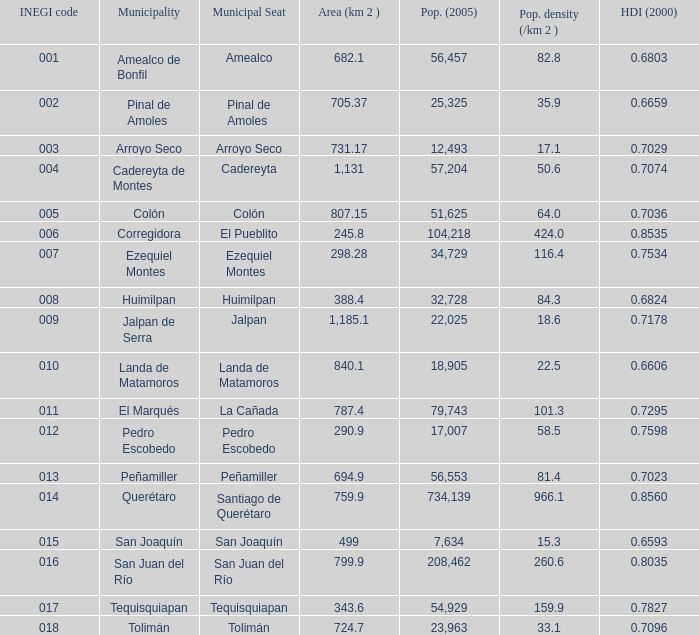WHich INEGI code has a Population density (/km 2 ) smaller than 81.4 and 0.6593 Human Development Index (2000)? 15.0. 